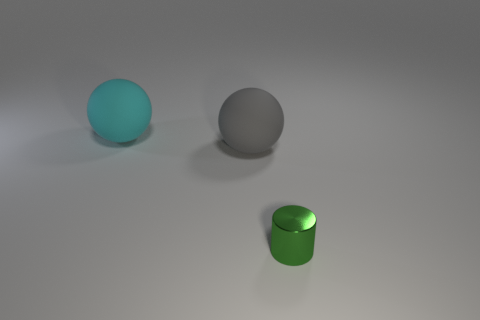Are there any other things that are the same size as the green metallic cylinder?
Make the answer very short. No. How many objects are big rubber balls in front of the big cyan thing or big gray objects?
Ensure brevity in your answer.  1. There is a green cylinder right of the large cyan rubber sphere; what size is it?
Ensure brevity in your answer.  Small. What is the cyan sphere made of?
Offer a terse response. Rubber. What is the shape of the large rubber object in front of the object that is behind the large gray object?
Provide a succinct answer. Sphere. How many other objects are the same shape as the cyan thing?
Make the answer very short. 1. There is a gray matte sphere; are there any small green cylinders left of it?
Make the answer very short. No. What color is the small object?
Offer a terse response. Green. There is a tiny cylinder; is its color the same as the big sphere in front of the cyan ball?
Offer a terse response. No. Are there any gray balls that have the same size as the green cylinder?
Your answer should be very brief. No. 